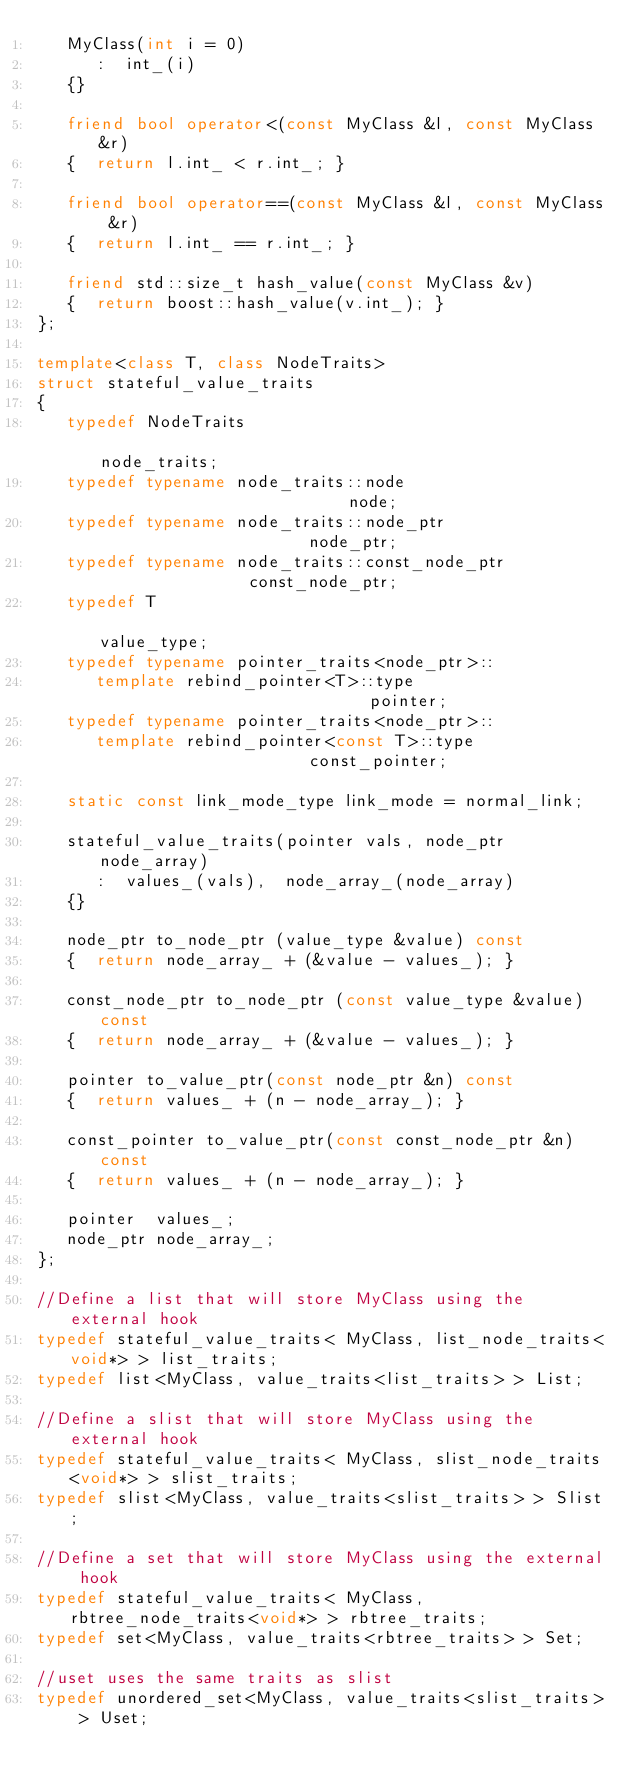Convert code to text. <code><loc_0><loc_0><loc_500><loc_500><_C++_>   MyClass(int i = 0)
      :  int_(i)
   {}

   friend bool operator<(const MyClass &l, const MyClass &r)
   {  return l.int_ < r.int_; }

   friend bool operator==(const MyClass &l, const MyClass &r)
   {  return l.int_ == r.int_; }

   friend std::size_t hash_value(const MyClass &v)
   {  return boost::hash_value(v.int_); }
};

template<class T, class NodeTraits>
struct stateful_value_traits
{
   typedef NodeTraits                                          node_traits;
   typedef typename node_traits::node                          node;
   typedef typename node_traits::node_ptr                      node_ptr;
   typedef typename node_traits::const_node_ptr                const_node_ptr;
   typedef T                                                   value_type;
   typedef typename pointer_traits<node_ptr>::
      template rebind_pointer<T>::type                         pointer;
   typedef typename pointer_traits<node_ptr>::
      template rebind_pointer<const T>::type                   const_pointer;

   static const link_mode_type link_mode = normal_link;

   stateful_value_traits(pointer vals, node_ptr node_array)
      :  values_(vals),  node_array_(node_array)
   {}

   node_ptr to_node_ptr (value_type &value) const
   {  return node_array_ + (&value - values_); }

   const_node_ptr to_node_ptr (const value_type &value) const
   {  return node_array_ + (&value - values_); }

   pointer to_value_ptr(const node_ptr &n) const
   {  return values_ + (n - node_array_); }

   const_pointer to_value_ptr(const const_node_ptr &n) const
   {  return values_ + (n - node_array_); }

   pointer  values_;
   node_ptr node_array_;
};

//Define a list that will store MyClass using the external hook
typedef stateful_value_traits< MyClass, list_node_traits<void*> > list_traits;
typedef list<MyClass, value_traits<list_traits> > List;

//Define a slist that will store MyClass using the external hook
typedef stateful_value_traits< MyClass, slist_node_traits<void*> > slist_traits;
typedef slist<MyClass, value_traits<slist_traits> > Slist;

//Define a set that will store MyClass using the external hook
typedef stateful_value_traits< MyClass, rbtree_node_traits<void*> > rbtree_traits;
typedef set<MyClass, value_traits<rbtree_traits> > Set;

//uset uses the same traits as slist
typedef unordered_set<MyClass, value_traits<slist_traits> > Uset;

</code> 